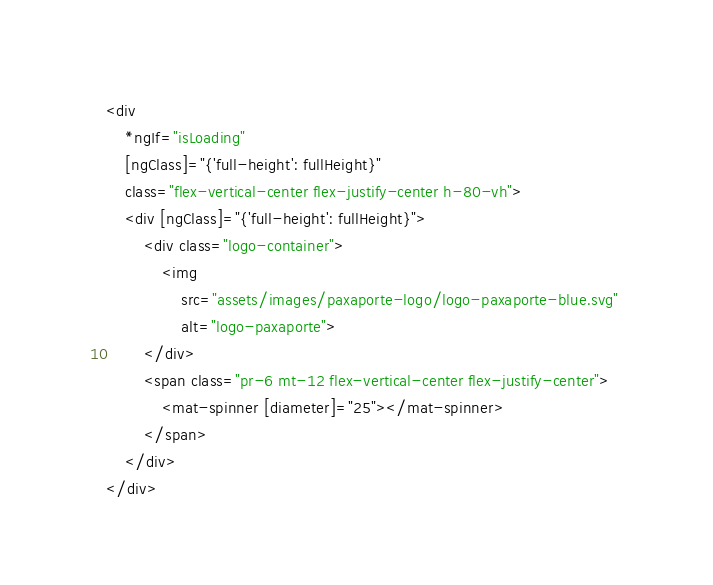<code> <loc_0><loc_0><loc_500><loc_500><_HTML_><div
    *ngIf="isLoading"
    [ngClass]="{'full-height': fullHeight}"
    class="flex-vertical-center flex-justify-center h-80-vh">
    <div [ngClass]="{'full-height': fullHeight}">
        <div class="logo-container">
            <img 
                src="assets/images/paxaporte-logo/logo-paxaporte-blue.svg" 
                alt="logo-paxaporte">
        </div>
        <span class="pr-6 mt-12 flex-vertical-center flex-justify-center">
            <mat-spinner [diameter]="25"></mat-spinner>
        </span>
    </div>
</div>
</code> 